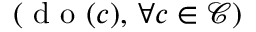<formula> <loc_0><loc_0><loc_500><loc_500>( d o ( c ) , \, \forall c \in \mathcal { C } )</formula> 